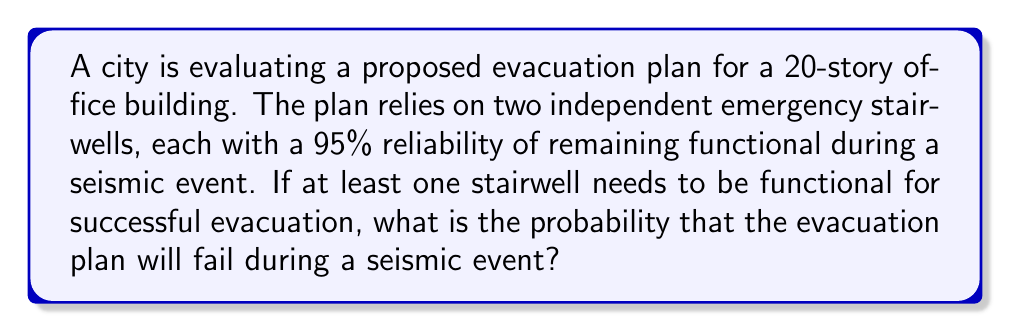Can you answer this question? Let's approach this step-by-step:

1) First, we need to understand what constitutes a failure of the evacuation plan. The plan fails if both stairwells become non-functional.

2) We're given that each stairwell has a 95% reliability, which means:
   P(stairwell functional) = 0.95
   P(stairwell non-functional) = 1 - 0.95 = 0.05

3) For the evacuation plan to fail, both stairwells must be non-functional. Since the stairwells are independent, we can multiply the probabilities:

   P(both non-functional) = P(stairwell 1 non-functional) × P(stairwell 2 non-functional)
                          = 0.05 × 0.05

4) Let's calculate this:
   
   $$P(\text{evacuation plan fails}) = 0.05 \times 0.05 = 0.0025$$

5) To convert to a percentage:
   
   $$0.0025 \times 100\% = 0.25\%$$

Thus, there is a 0.25% chance that the evacuation plan will fail during a seismic event.
Answer: 0.25% 